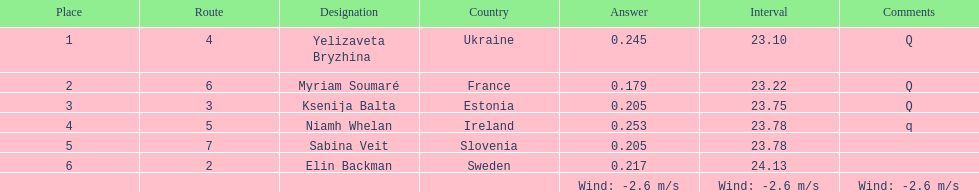Who is the first ranking player? Yelizaveta Bryzhina. 